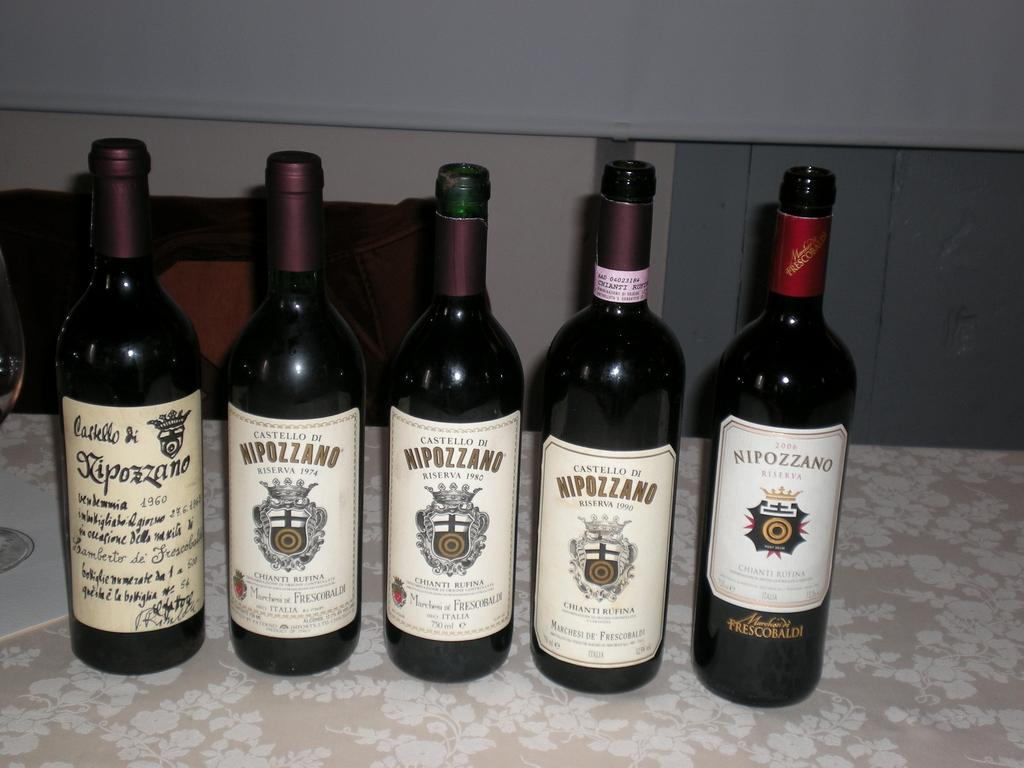<image>
Write a terse but informative summary of the picture. 5 bottles of wine bottled by the company Nipozzano 